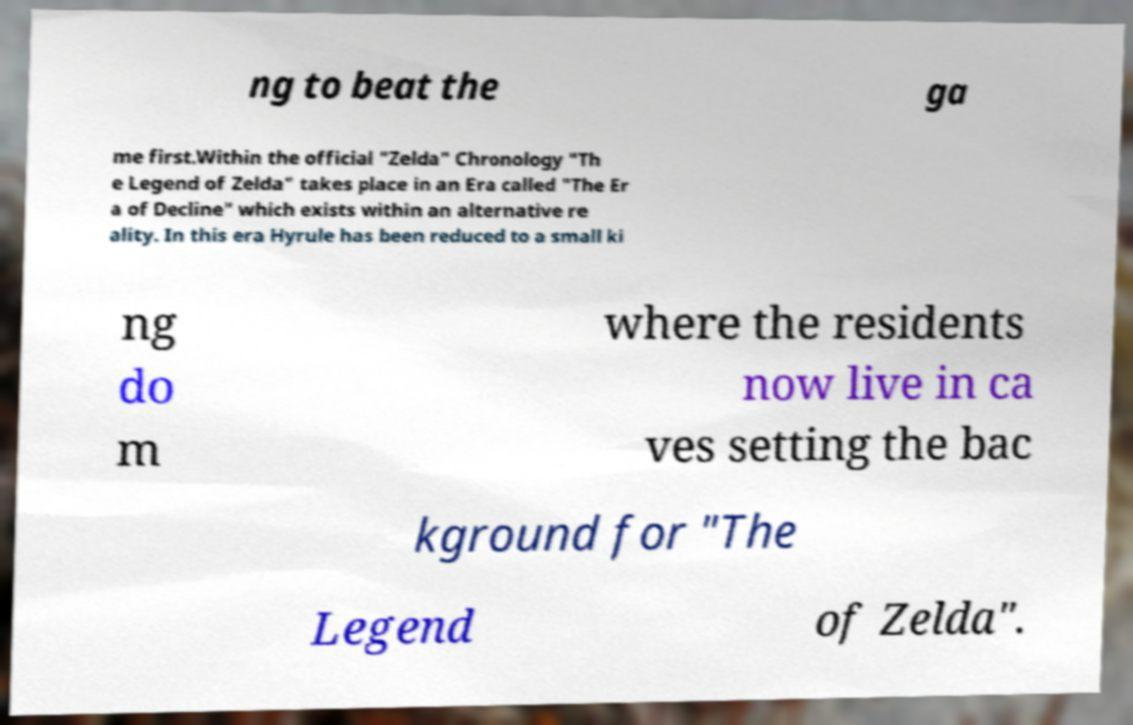Can you accurately transcribe the text from the provided image for me? ng to beat the ga me first.Within the official "Zelda" Chronology "Th e Legend of Zelda" takes place in an Era called "The Er a of Decline" which exists within an alternative re ality. In this era Hyrule has been reduced to a small ki ng do m where the residents now live in ca ves setting the bac kground for "The Legend of Zelda". 